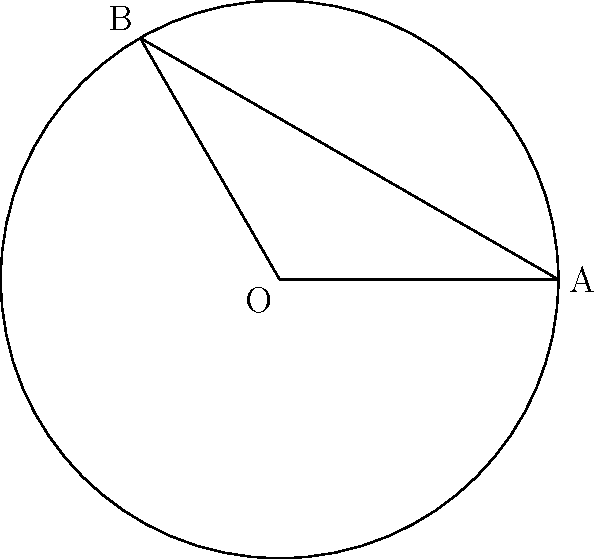In the circle above, imagine the smooth curves of a jazz saxophone. The radius (r) represents the length of the instrument, which is 3 units long. The central angle ($\theta$) between two notes on the musical scale is 120°. Calculate the length of the chord (AB) connecting these two notes, reminiscent of the connection between Pharoah Sanders' free jazz improvisations. Let's break this down step-by-step, much like dissecting a complex jazz composition:

1) We're given:
   - Radius (r) = 3 units
   - Central angle ($\theta$) = 120° = $\frac{2\pi}{3}$ radians

2) The formula for chord length (c) in a circle is:
   $c = 2r \sin(\frac{\theta}{2})$

3) Let's substitute our values:
   $c = 2 \cdot 3 \cdot \sin(\frac{120°}{2})$
   $c = 6 \cdot \sin(60°)$

4) We know that $\sin(60°) = \frac{\sqrt{3}}{2}$

5) Therefore:
   $c = 6 \cdot \frac{\sqrt{3}}{2}$
   $c = 3\sqrt{3}$

6) This can be left as is, or if we want a decimal approximation:
   $c \approx 5.196$ units

Just as Pharoah Sanders bridged different styles in jazz, this chord bridges two points on our musical circle, with a length of $3\sqrt{3}$ units.
Answer: $3\sqrt{3}$ units 